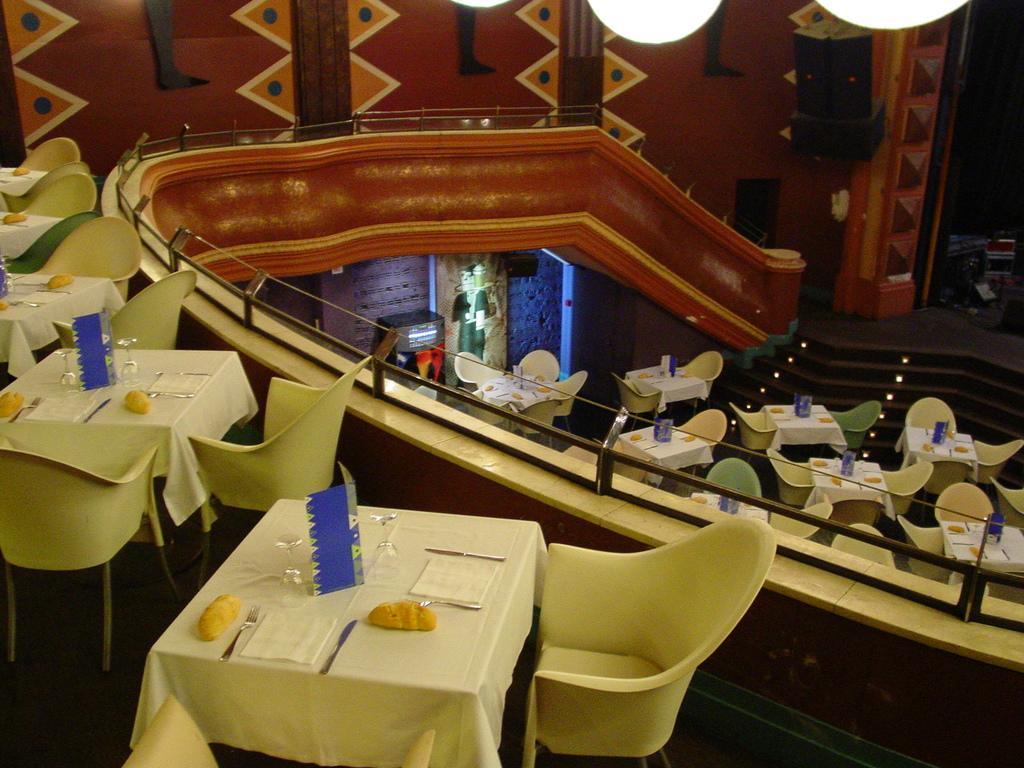In one or two sentences, can you explain what this image depicts? In this picture I can see the tables in front, on which there are glasses, spoons, forks, knives, clothes and other things and I can also see the chairs. In the center of this picture I can see the railing, steps, few more tables and chairs. In the background I can see the wall on which there are designs. On the top right of this picture I can see the lights. 